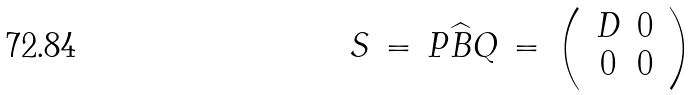<formula> <loc_0><loc_0><loc_500><loc_500>S \, = \, P \widehat { B } Q \, = \, \left ( \, \begin{array} { c c } D & 0 \\ 0 & 0 \end{array} \, \right )</formula> 